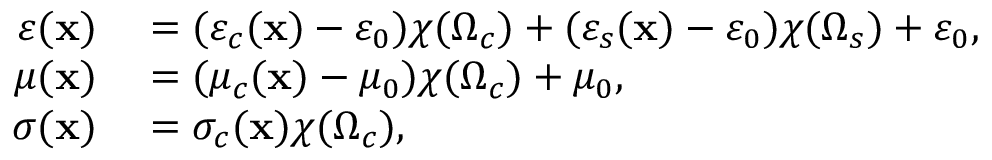<formula> <loc_0><loc_0><loc_500><loc_500>\begin{array} { r l } { \varepsilon ( x ) } & = ( \varepsilon _ { c } ( x ) - \varepsilon _ { 0 } ) \chi ( \Omega _ { c } ) + ( \varepsilon _ { s } ( x ) - \varepsilon _ { 0 } ) \chi ( \Omega _ { s } ) + \varepsilon _ { 0 } , } \\ { \mu ( x ) } & = ( \mu _ { c } ( x ) - \mu _ { 0 } ) \chi ( \Omega _ { c } ) + \mu _ { 0 } , } \\ { \sigma ( x ) } & = \sigma _ { c } ( x ) \chi ( \Omega _ { c } ) , } \end{array}</formula> 